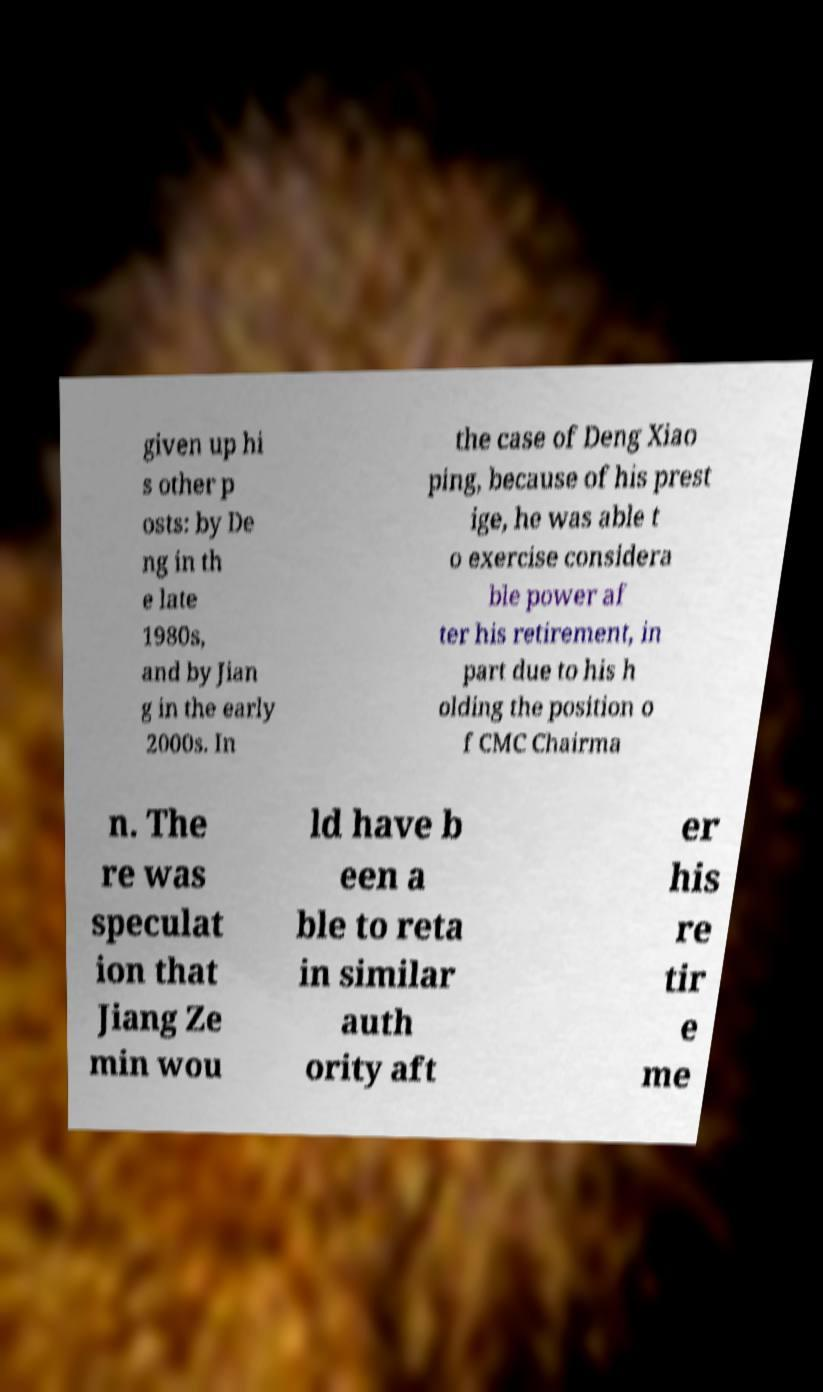Can you accurately transcribe the text from the provided image for me? given up hi s other p osts: by De ng in th e late 1980s, and by Jian g in the early 2000s. In the case of Deng Xiao ping, because of his prest ige, he was able t o exercise considera ble power af ter his retirement, in part due to his h olding the position o f CMC Chairma n. The re was speculat ion that Jiang Ze min wou ld have b een a ble to reta in similar auth ority aft er his re tir e me 